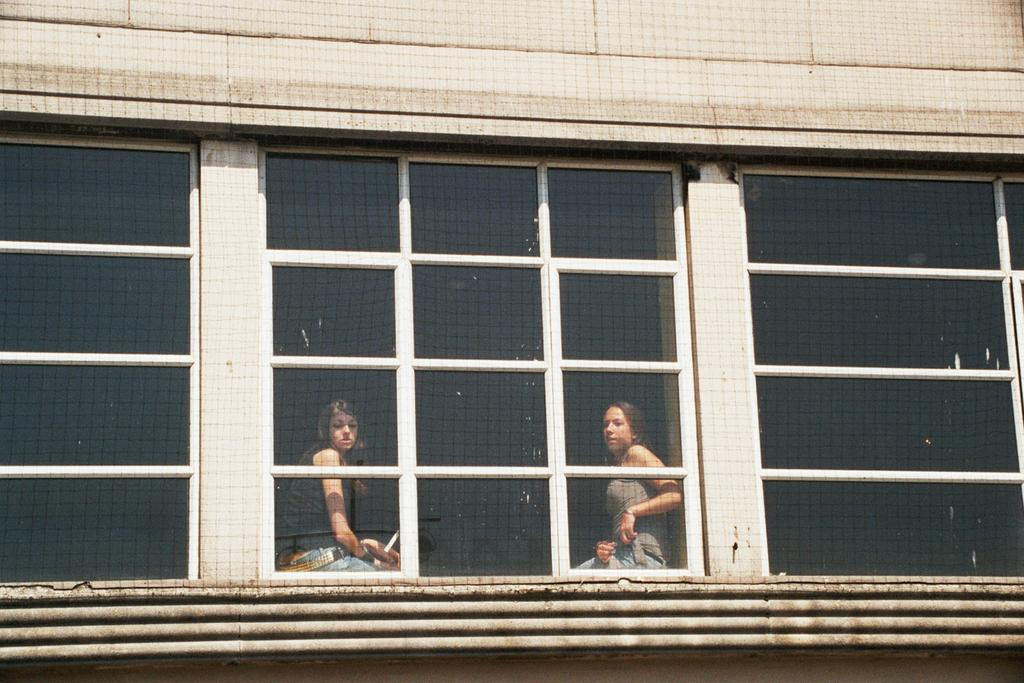How many people are in the image? There are two persons in the image. What are the persons wearing? The persons are wearing clothes. Where are the persons sitting in the image? The persons are sitting on a window. How many windows can be seen in the image? There are three windows in the image: one on the left side, one on the right side, and the one the persons are sitting on. What type of stream can be seen flowing through the image? There is no stream present in the image; it features two persons sitting on a window and three windows in total. 